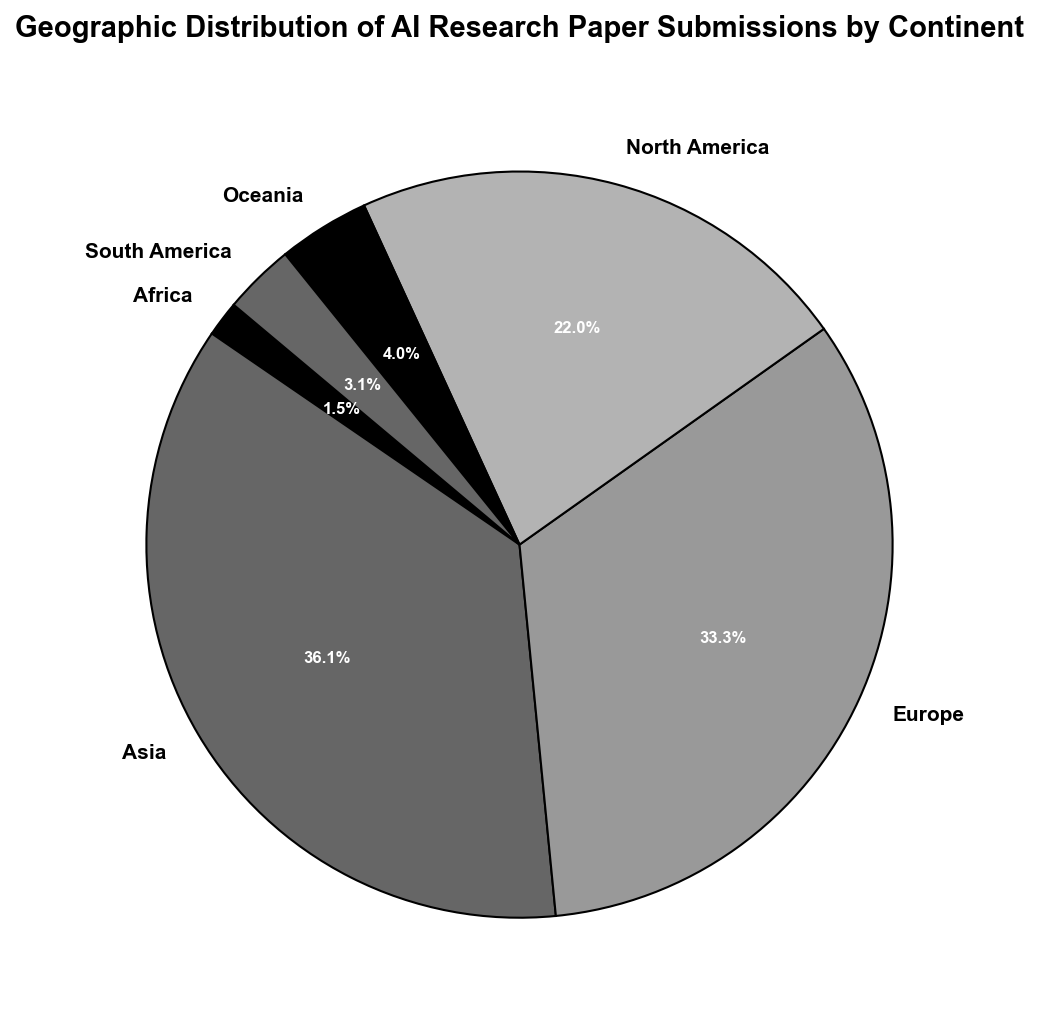What percentage of AI research paper submissions comes from Asia? Based on the pie chart, look at the slice representing Asia and read the percentage label associated with it.
Answer: 38.7% Which continent has the highest number of AI research paper submissions? Identify the largest slice in the pie chart and read its label to find the continent with the highest submissions.
Answer: North America How do the combined submissions from Europe and Asia compare to the submissions from North America? Sum the percentages of Europe and Asia and compare it to the percentage of North America. Europe is 19.4% and Asia is 38.7%, making their combined total 58.1%, while North America is 38.1%.
Answer: Europe and Asia have more submissions than North America What percentage of AI research paper submissions comes from continents other than Asia and North America? Sum the percentages of all other continent slices except Asia and North America. Europe is 19.4%, South America is 3.0%, Oceania is 2.9%, and Africa is 1.6%. Total is 19.4 + 3.0 + 2.9 + 1.6 = 26.9%.
Answer: 26.9% If you combine the submissions from Oceania and South America, do they exceed the submissions from Africa? Compare the sum of the percentages for Oceania and South America to Africa. Oceania is 2.9%, and South America is 3.0%, their combined total is 5.9%. Africa is 1.6%. 5.9% is greater than 1.6%.
Answer: Yes What is the difference in submission percentages between the continent with the most and the continent with the least submissions? Identify the continent with the most submissions (North America, 38.1%) and the least submissions (Africa, 1.6%), then subtract the smallest percentage from the largest. 38.1% - 1.6% = 36.5%.
Answer: 36.5% We know Europe contributed 19.4% of the total submissions. What fraction of the total submissions does Africa contribute compared to Europe? Calculate the fraction of Africa's percentage (1.6%) to Europe's percentage (19.4%) by dividing them. 1.6% / 19.4% = 0.0825 or approximately 8.3%.
Answer: Approximately 8.3% Is the percentage of submissions from Oceania closer to that of South America or Africa? Compare the percentage of submissions from Oceania (2.9%) to those from South America (3.0%) and Africa (1.6%). The difference to South America is 3.0% - 2.9% = 0.1%, and to Africa is 2.9% - 1.6% = 1.3%.
Answer: South America What rank does Europe hold in terms of the percentage of submissions? Rank the continents by their submission percentages and determine Europe's position in the order. North America is first (38.1%), Asia is second (38.7%), and Europe is third (19.4%).
Answer: Third in rank 